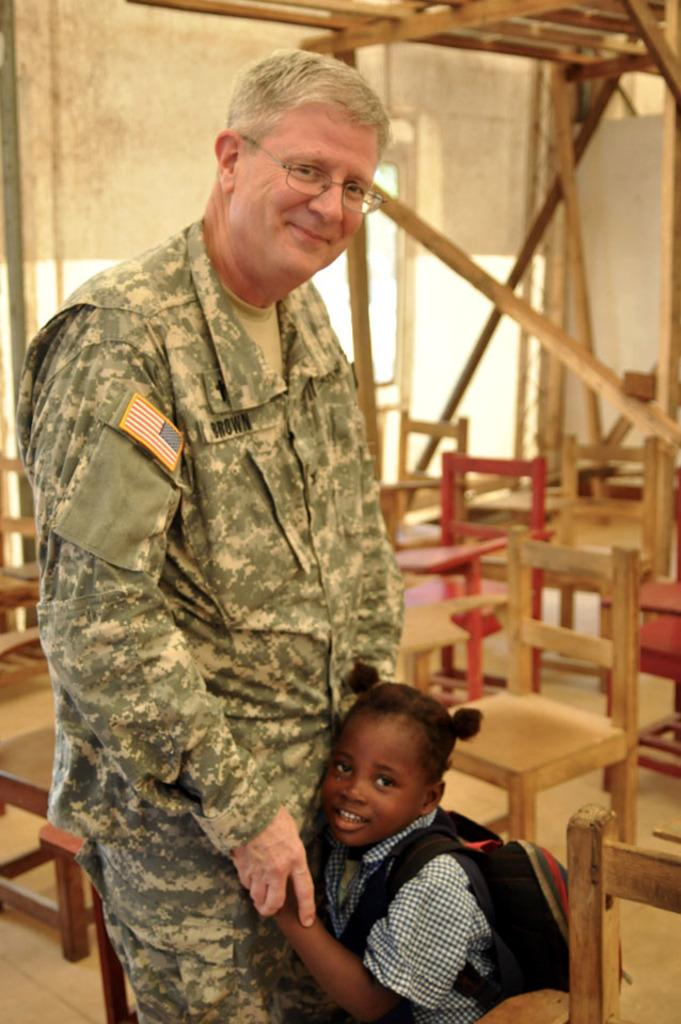Who is present in the image? There is a man and a girl child in the image. What is the man wearing? The man is wearing an army dress. What are the man and the girl child doing in the image? The man and the girl child are standing together. What can be seen in the background of the image? There are chairs visible in the background of the image. How many fingers does the man have on his left hand in the image? There is no information provided about the man's fingers in the image, so we cannot determine the number of fingers on his left hand. Are there any horses present in the image? No, there are no horses present in the image. 